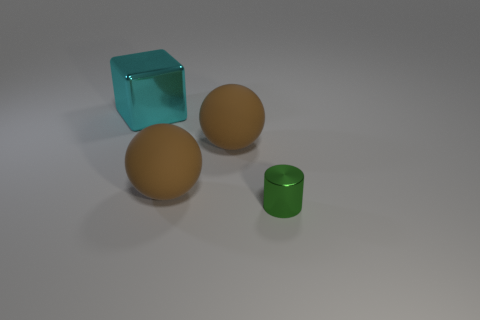What number of gray rubber blocks are there?
Your answer should be very brief. 0. Is the number of brown objects that are in front of the small green cylinder less than the number of cyan things?
Give a very brief answer. Yes. Do the metallic object that is to the right of the large cyan object and the large cyan thing have the same shape?
Your response must be concise. No. Are there any other things that are the same color as the large cube?
Offer a very short reply. No. What size is the cyan block that is the same material as the green cylinder?
Give a very brief answer. Large. Is the number of cylinders less than the number of tiny cyan matte cylinders?
Your answer should be very brief. No. There is a shiny object in front of the big cube; what number of shiny objects are behind it?
Keep it short and to the point. 1. There is a tiny metallic thing; what shape is it?
Your response must be concise. Cylinder. How many brown matte things have the same shape as the tiny metal thing?
Keep it short and to the point. 0. How many objects are behind the tiny thing and on the right side of the cyan object?
Keep it short and to the point. 2. 